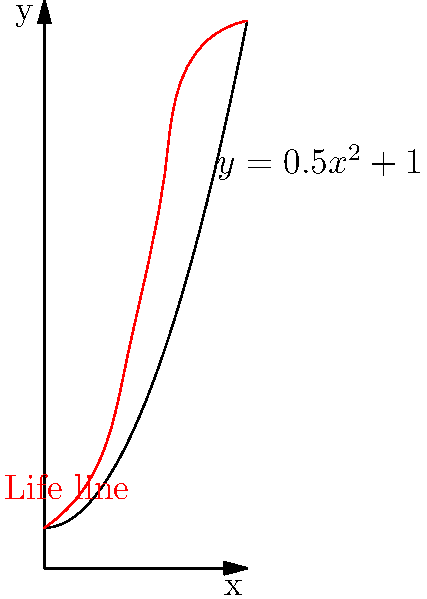A palmist has modeled a client's life line using the function $f(x)=0.5x^2+1$, where $x$ represents years (0 to 5) and $f(x)$ represents life energy. Calculate the total life energy experienced over these 5 years by finding the area under the curve. To find the area under the curve, we need to integrate the function $f(x)=0.5x^2+1$ from $x=0$ to $x=5$. Here's how we do it:

1) Set up the definite integral:
   $$\int_0^5 (0.5x^2+1) dx$$

2) Integrate the function:
   $$\left[\frac{1}{6}x^3 + x\right]_0^5$$

3) Evaluate the integral at the upper and lower bounds:
   $$\left(\frac{1}{6}(5^3) + 5\right) - \left(\frac{1}{6}(0^3) + 0\right)$$

4) Simplify:
   $$\left(\frac{125}{6} + 5\right) - 0 = \frac{125}{6} + 5 = \frac{125}{6} + \frac{30}{6} = \frac{155}{6}$$

5) Calculate the final result:
   $$\frac{155}{6} \approx 25.83$$

Thus, the total life energy experienced over these 5 years is approximately 25.83 units.
Answer: $\frac{155}{6}$ or approximately 25.83 units 